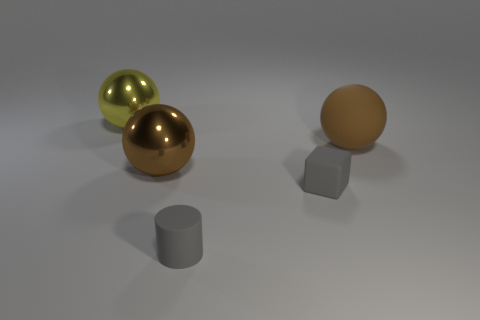Subtract 1 balls. How many balls are left? 2 Add 1 blue matte cubes. How many objects exist? 6 Subtract all cylinders. How many objects are left? 4 Add 3 small matte cylinders. How many small matte cylinders are left? 4 Add 4 brown metallic balls. How many brown metallic balls exist? 5 Subtract 0 green spheres. How many objects are left? 5 Subtract all tiny things. Subtract all rubber balls. How many objects are left? 2 